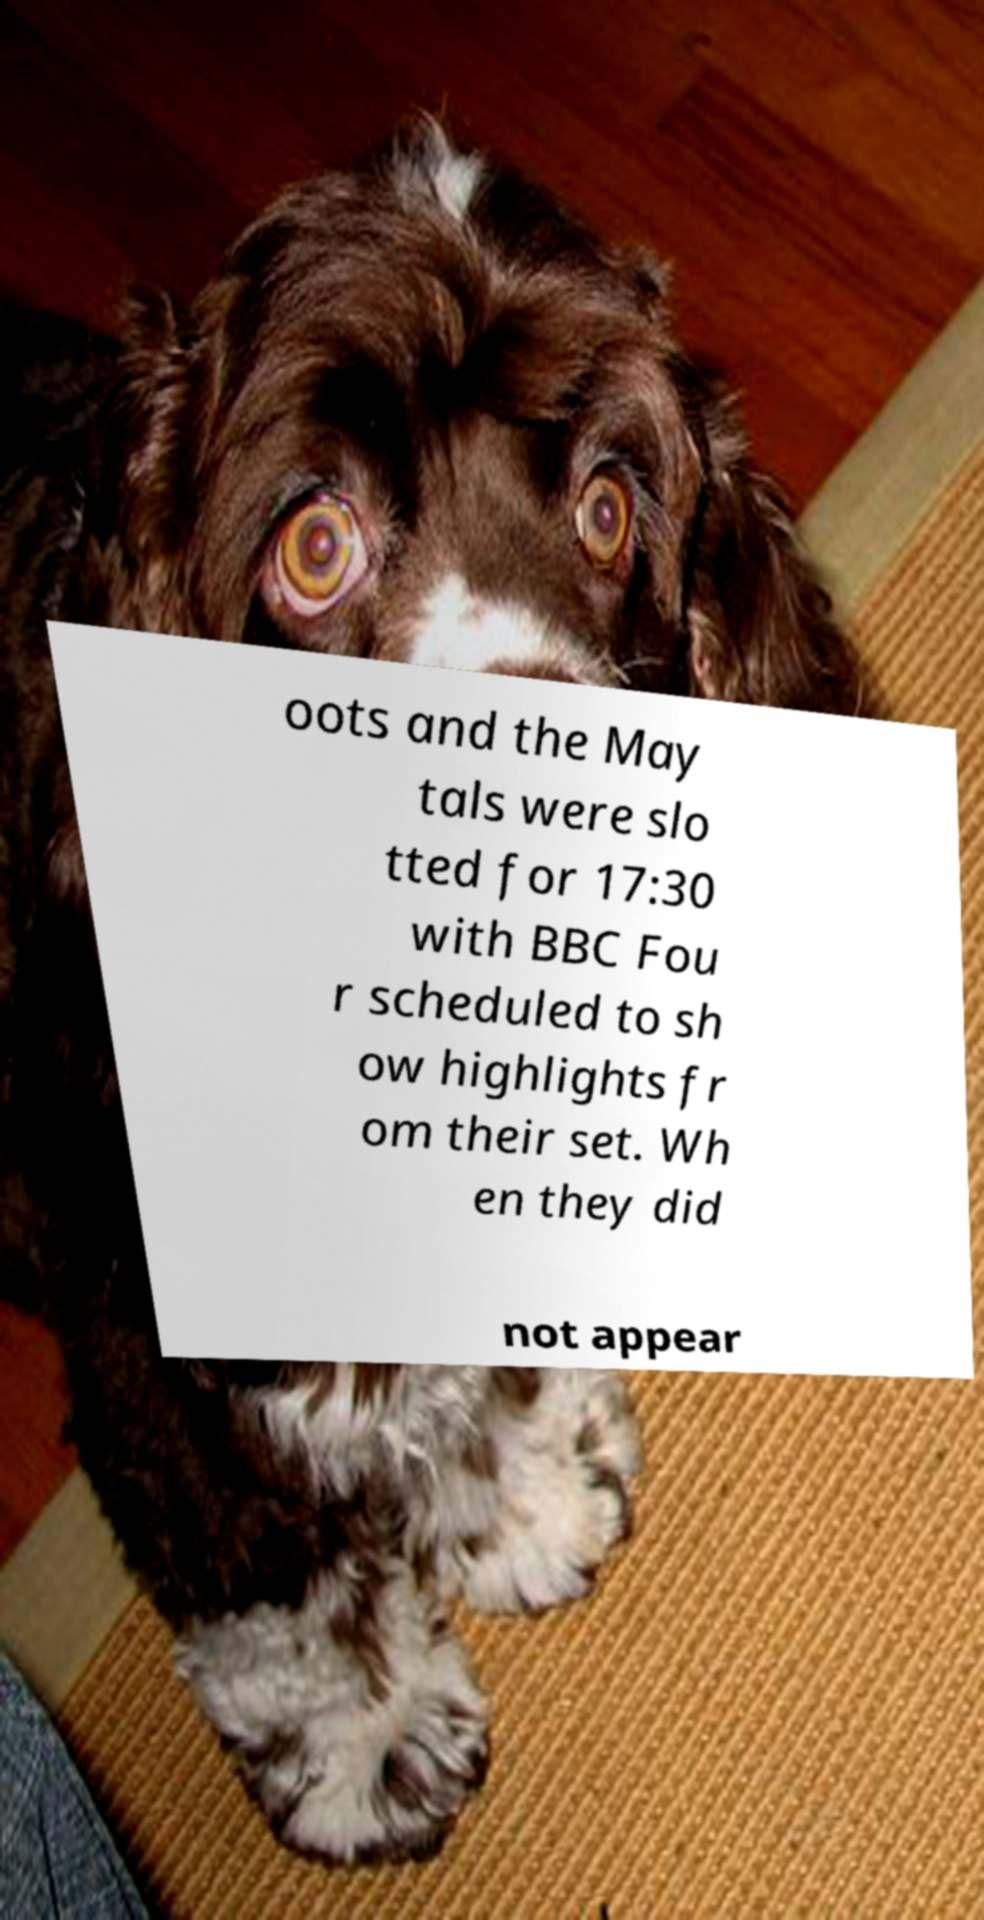Could you assist in decoding the text presented in this image and type it out clearly? oots and the May tals were slo tted for 17:30 with BBC Fou r scheduled to sh ow highlights fr om their set. Wh en they did not appear 